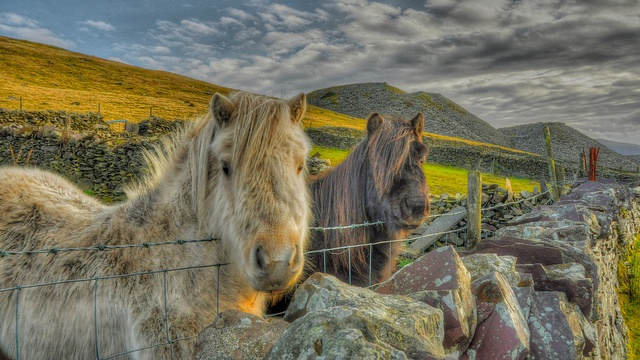Describe the objects in this image and their specific colors. I can see horse in gray and darkgray tones and horse in gray and black tones in this image. 